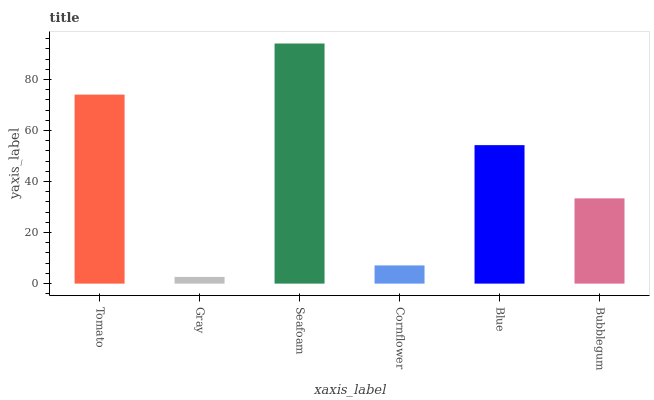Is Gray the minimum?
Answer yes or no. Yes. Is Seafoam the maximum?
Answer yes or no. Yes. Is Seafoam the minimum?
Answer yes or no. No. Is Gray the maximum?
Answer yes or no. No. Is Seafoam greater than Gray?
Answer yes or no. Yes. Is Gray less than Seafoam?
Answer yes or no. Yes. Is Gray greater than Seafoam?
Answer yes or no. No. Is Seafoam less than Gray?
Answer yes or no. No. Is Blue the high median?
Answer yes or no. Yes. Is Bubblegum the low median?
Answer yes or no. Yes. Is Gray the high median?
Answer yes or no. No. Is Tomato the low median?
Answer yes or no. No. 